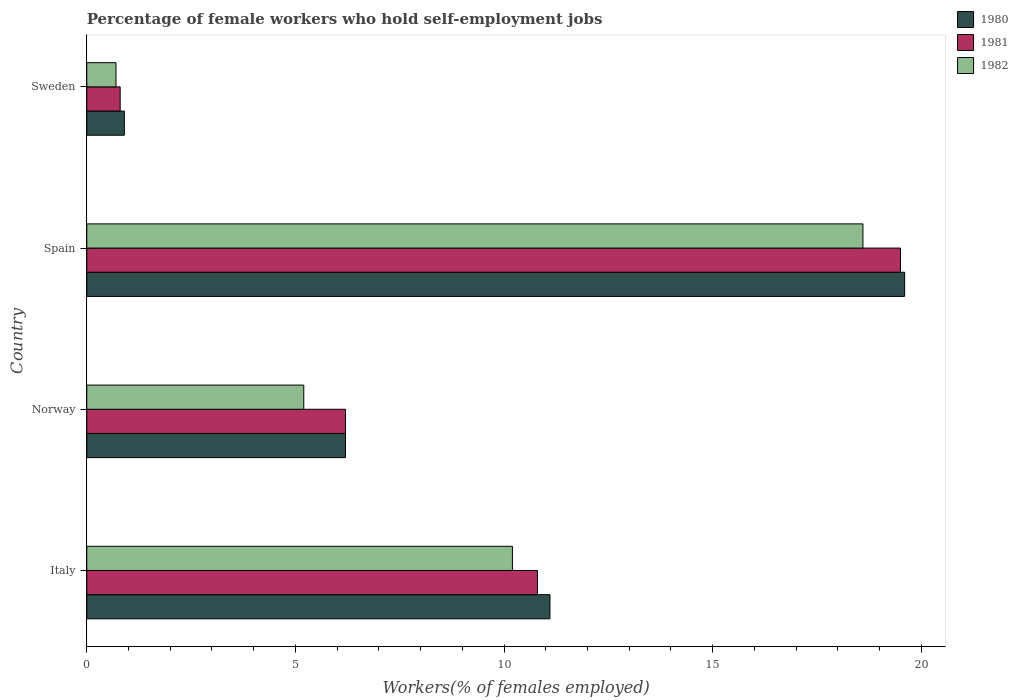How many different coloured bars are there?
Your response must be concise. 3. Are the number of bars per tick equal to the number of legend labels?
Offer a very short reply. Yes. How many bars are there on the 1st tick from the bottom?
Give a very brief answer. 3. In how many cases, is the number of bars for a given country not equal to the number of legend labels?
Your answer should be very brief. 0. What is the percentage of self-employed female workers in 1980 in Sweden?
Your response must be concise. 0.9. Across all countries, what is the maximum percentage of self-employed female workers in 1980?
Offer a terse response. 19.6. Across all countries, what is the minimum percentage of self-employed female workers in 1982?
Make the answer very short. 0.7. What is the total percentage of self-employed female workers in 1980 in the graph?
Offer a very short reply. 37.8. What is the difference between the percentage of self-employed female workers in 1981 in Italy and that in Spain?
Keep it short and to the point. -8.7. What is the difference between the percentage of self-employed female workers in 1982 in Spain and the percentage of self-employed female workers in 1980 in Sweden?
Your response must be concise. 17.7. What is the average percentage of self-employed female workers in 1980 per country?
Make the answer very short. 9.45. What is the difference between the percentage of self-employed female workers in 1981 and percentage of self-employed female workers in 1980 in Norway?
Give a very brief answer. 0. In how many countries, is the percentage of self-employed female workers in 1982 greater than 7 %?
Give a very brief answer. 2. What is the ratio of the percentage of self-employed female workers in 1981 in Norway to that in Sweden?
Provide a succinct answer. 7.75. Is the percentage of self-employed female workers in 1981 in Italy less than that in Sweden?
Your response must be concise. No. What is the difference between the highest and the second highest percentage of self-employed female workers in 1982?
Provide a short and direct response. 8.4. What is the difference between the highest and the lowest percentage of self-employed female workers in 1980?
Offer a terse response. 18.7. In how many countries, is the percentage of self-employed female workers in 1982 greater than the average percentage of self-employed female workers in 1982 taken over all countries?
Give a very brief answer. 2. Are all the bars in the graph horizontal?
Ensure brevity in your answer.  Yes. Are the values on the major ticks of X-axis written in scientific E-notation?
Provide a succinct answer. No. Does the graph contain grids?
Offer a very short reply. No. Where does the legend appear in the graph?
Provide a short and direct response. Top right. How many legend labels are there?
Offer a very short reply. 3. How are the legend labels stacked?
Give a very brief answer. Vertical. What is the title of the graph?
Ensure brevity in your answer.  Percentage of female workers who hold self-employment jobs. What is the label or title of the X-axis?
Make the answer very short. Workers(% of females employed). What is the label or title of the Y-axis?
Keep it short and to the point. Country. What is the Workers(% of females employed) of 1980 in Italy?
Your answer should be very brief. 11.1. What is the Workers(% of females employed) of 1981 in Italy?
Provide a short and direct response. 10.8. What is the Workers(% of females employed) of 1982 in Italy?
Make the answer very short. 10.2. What is the Workers(% of females employed) of 1980 in Norway?
Offer a very short reply. 6.2. What is the Workers(% of females employed) of 1981 in Norway?
Keep it short and to the point. 6.2. What is the Workers(% of females employed) in 1982 in Norway?
Offer a terse response. 5.2. What is the Workers(% of females employed) of 1980 in Spain?
Your response must be concise. 19.6. What is the Workers(% of females employed) in 1981 in Spain?
Give a very brief answer. 19.5. What is the Workers(% of females employed) in 1982 in Spain?
Offer a terse response. 18.6. What is the Workers(% of females employed) of 1980 in Sweden?
Your answer should be compact. 0.9. What is the Workers(% of females employed) of 1981 in Sweden?
Your answer should be compact. 0.8. What is the Workers(% of females employed) of 1982 in Sweden?
Offer a terse response. 0.7. Across all countries, what is the maximum Workers(% of females employed) of 1980?
Make the answer very short. 19.6. Across all countries, what is the maximum Workers(% of females employed) of 1981?
Your answer should be very brief. 19.5. Across all countries, what is the maximum Workers(% of females employed) of 1982?
Make the answer very short. 18.6. Across all countries, what is the minimum Workers(% of females employed) in 1980?
Offer a terse response. 0.9. Across all countries, what is the minimum Workers(% of females employed) in 1981?
Provide a succinct answer. 0.8. Across all countries, what is the minimum Workers(% of females employed) in 1982?
Your answer should be compact. 0.7. What is the total Workers(% of females employed) in 1980 in the graph?
Your answer should be very brief. 37.8. What is the total Workers(% of females employed) of 1981 in the graph?
Your answer should be very brief. 37.3. What is the total Workers(% of females employed) of 1982 in the graph?
Keep it short and to the point. 34.7. What is the difference between the Workers(% of females employed) of 1981 in Italy and that in Norway?
Provide a succinct answer. 4.6. What is the difference between the Workers(% of females employed) in 1981 in Italy and that in Spain?
Offer a terse response. -8.7. What is the difference between the Workers(% of females employed) in 1980 in Italy and that in Sweden?
Your response must be concise. 10.2. What is the difference between the Workers(% of females employed) of 1981 in Italy and that in Sweden?
Ensure brevity in your answer.  10. What is the difference between the Workers(% of females employed) of 1982 in Italy and that in Sweden?
Your response must be concise. 9.5. What is the difference between the Workers(% of females employed) in 1981 in Norway and that in Spain?
Keep it short and to the point. -13.3. What is the difference between the Workers(% of females employed) in 1980 in Norway and that in Sweden?
Offer a terse response. 5.3. What is the difference between the Workers(% of females employed) in 1981 in Norway and that in Sweden?
Offer a terse response. 5.4. What is the difference between the Workers(% of females employed) in 1980 in Spain and that in Sweden?
Give a very brief answer. 18.7. What is the difference between the Workers(% of females employed) in 1980 in Italy and the Workers(% of females employed) in 1981 in Norway?
Provide a short and direct response. 4.9. What is the difference between the Workers(% of females employed) in 1980 in Italy and the Workers(% of females employed) in 1982 in Norway?
Provide a succinct answer. 5.9. What is the difference between the Workers(% of females employed) in 1980 in Italy and the Workers(% of females employed) in 1981 in Spain?
Offer a terse response. -8.4. What is the difference between the Workers(% of females employed) in 1980 in Italy and the Workers(% of females employed) in 1982 in Spain?
Make the answer very short. -7.5. What is the difference between the Workers(% of females employed) of 1981 in Norway and the Workers(% of females employed) of 1982 in Spain?
Provide a short and direct response. -12.4. What is the difference between the Workers(% of females employed) of 1980 in Norway and the Workers(% of females employed) of 1981 in Sweden?
Make the answer very short. 5.4. What is the difference between the Workers(% of females employed) of 1981 in Norway and the Workers(% of females employed) of 1982 in Sweden?
Make the answer very short. 5.5. What is the difference between the Workers(% of females employed) in 1980 in Spain and the Workers(% of females employed) in 1981 in Sweden?
Keep it short and to the point. 18.8. What is the average Workers(% of females employed) of 1980 per country?
Provide a succinct answer. 9.45. What is the average Workers(% of females employed) of 1981 per country?
Provide a short and direct response. 9.32. What is the average Workers(% of females employed) in 1982 per country?
Provide a short and direct response. 8.68. What is the difference between the Workers(% of females employed) of 1980 and Workers(% of females employed) of 1982 in Italy?
Your answer should be very brief. 0.9. What is the difference between the Workers(% of females employed) in 1981 and Workers(% of females employed) in 1982 in Italy?
Give a very brief answer. 0.6. What is the difference between the Workers(% of females employed) in 1981 and Workers(% of females employed) in 1982 in Spain?
Your answer should be very brief. 0.9. What is the difference between the Workers(% of females employed) in 1980 and Workers(% of females employed) in 1981 in Sweden?
Your answer should be very brief. 0.1. What is the difference between the Workers(% of females employed) of 1981 and Workers(% of females employed) of 1982 in Sweden?
Offer a terse response. 0.1. What is the ratio of the Workers(% of females employed) of 1980 in Italy to that in Norway?
Your answer should be compact. 1.79. What is the ratio of the Workers(% of females employed) in 1981 in Italy to that in Norway?
Keep it short and to the point. 1.74. What is the ratio of the Workers(% of females employed) in 1982 in Italy to that in Norway?
Offer a very short reply. 1.96. What is the ratio of the Workers(% of females employed) in 1980 in Italy to that in Spain?
Provide a succinct answer. 0.57. What is the ratio of the Workers(% of females employed) of 1981 in Italy to that in Spain?
Your answer should be very brief. 0.55. What is the ratio of the Workers(% of females employed) of 1982 in Italy to that in Spain?
Your answer should be very brief. 0.55. What is the ratio of the Workers(% of females employed) in 1980 in Italy to that in Sweden?
Give a very brief answer. 12.33. What is the ratio of the Workers(% of females employed) of 1982 in Italy to that in Sweden?
Give a very brief answer. 14.57. What is the ratio of the Workers(% of females employed) of 1980 in Norway to that in Spain?
Offer a terse response. 0.32. What is the ratio of the Workers(% of females employed) in 1981 in Norway to that in Spain?
Ensure brevity in your answer.  0.32. What is the ratio of the Workers(% of females employed) in 1982 in Norway to that in Spain?
Your answer should be compact. 0.28. What is the ratio of the Workers(% of females employed) of 1980 in Norway to that in Sweden?
Offer a very short reply. 6.89. What is the ratio of the Workers(% of females employed) in 1981 in Norway to that in Sweden?
Your response must be concise. 7.75. What is the ratio of the Workers(% of females employed) of 1982 in Norway to that in Sweden?
Provide a succinct answer. 7.43. What is the ratio of the Workers(% of females employed) of 1980 in Spain to that in Sweden?
Your response must be concise. 21.78. What is the ratio of the Workers(% of females employed) of 1981 in Spain to that in Sweden?
Ensure brevity in your answer.  24.38. What is the ratio of the Workers(% of females employed) in 1982 in Spain to that in Sweden?
Provide a succinct answer. 26.57. What is the difference between the highest and the second highest Workers(% of females employed) of 1981?
Provide a succinct answer. 8.7. What is the difference between the highest and the second highest Workers(% of females employed) in 1982?
Offer a very short reply. 8.4. What is the difference between the highest and the lowest Workers(% of females employed) in 1980?
Give a very brief answer. 18.7. What is the difference between the highest and the lowest Workers(% of females employed) in 1982?
Offer a very short reply. 17.9. 